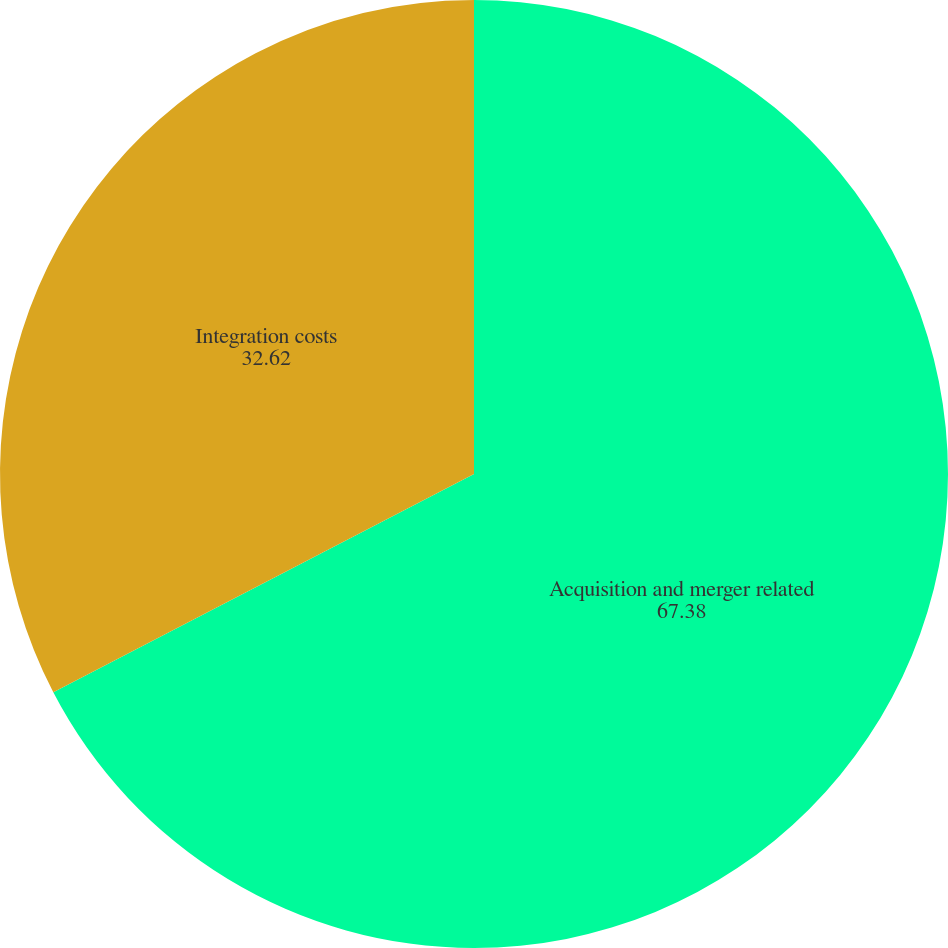Convert chart. <chart><loc_0><loc_0><loc_500><loc_500><pie_chart><fcel>Acquisition and merger related<fcel>Integration costs<nl><fcel>67.38%<fcel>32.62%<nl></chart> 